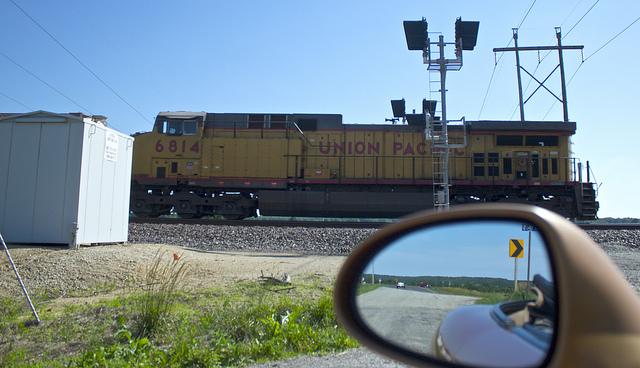What shape is the mirror?
Answer briefly. Oval. What railroad does this train belong?
Concise answer only. Union pacific. What is the person holding in the mirror?
Keep it brief. Nothing. Is this man in a car or motorcycle?
Write a very short answer. Car. What direction is the arrow in the rear-view mirror facing?
Give a very brief answer. Right. Is the sky clear?
Keep it brief. Yes. Are there any people?
Concise answer only. No. Where is the cargo containers?
Answer briefly. On train. Is the man's face reflected in the mirror?
Concise answer only. No. 